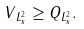<formula> <loc_0><loc_0><loc_500><loc_500>\| V \| _ { L _ { x } ^ { 2 } } \geq \| Q \| _ { L _ { x } ^ { 2 } } .</formula> 